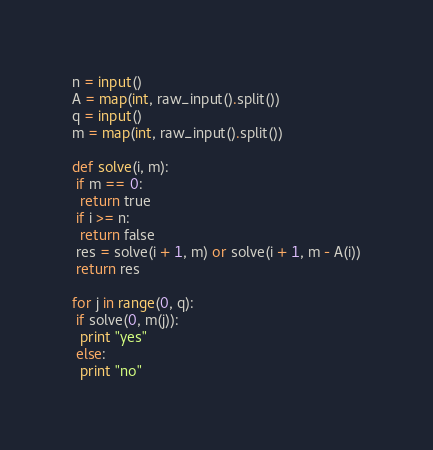Convert code to text. <code><loc_0><loc_0><loc_500><loc_500><_Python_>n = input()
A = map(int, raw_input().split())
q = input()
m = map(int, raw_input().split())

def solve(i, m):
 if m == 0:
  return true
 if i >= n:
  return false
 res = solve(i + 1, m) or solve(i + 1, m - A(i))
 return res

for j in range(0, q):
 if solve(0, m(j)):
  print "yes"
 else:
  print "no"</code> 